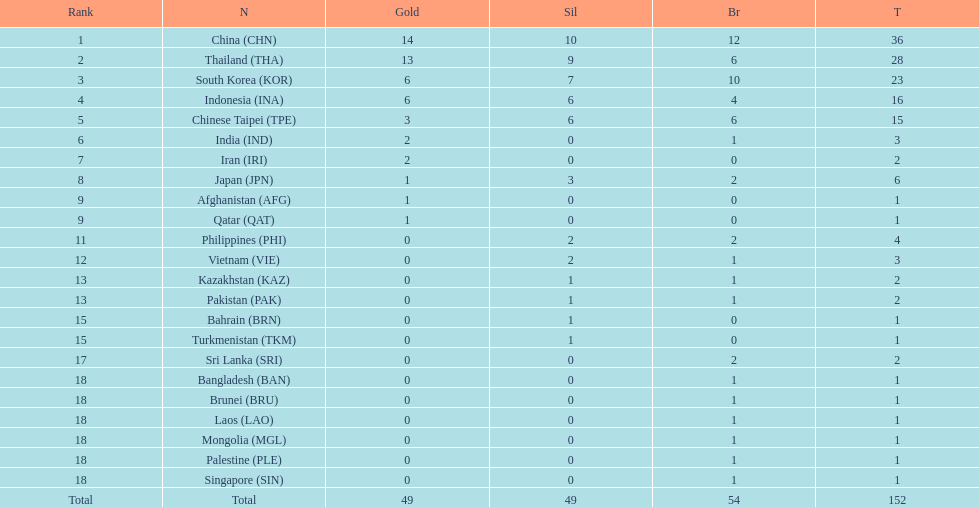What was the total of medals secured by indonesia (ina)? 16. Give me the full table as a dictionary. {'header': ['Rank', 'N', 'Gold', 'Sil', 'Br', 'T'], 'rows': [['1', 'China\xa0(CHN)', '14', '10', '12', '36'], ['2', 'Thailand\xa0(THA)', '13', '9', '6', '28'], ['3', 'South Korea\xa0(KOR)', '6', '7', '10', '23'], ['4', 'Indonesia\xa0(INA)', '6', '6', '4', '16'], ['5', 'Chinese Taipei\xa0(TPE)', '3', '6', '6', '15'], ['6', 'India\xa0(IND)', '2', '0', '1', '3'], ['7', 'Iran\xa0(IRI)', '2', '0', '0', '2'], ['8', 'Japan\xa0(JPN)', '1', '3', '2', '6'], ['9', 'Afghanistan\xa0(AFG)', '1', '0', '0', '1'], ['9', 'Qatar\xa0(QAT)', '1', '0', '0', '1'], ['11', 'Philippines\xa0(PHI)', '0', '2', '2', '4'], ['12', 'Vietnam\xa0(VIE)', '0', '2', '1', '3'], ['13', 'Kazakhstan\xa0(KAZ)', '0', '1', '1', '2'], ['13', 'Pakistan\xa0(PAK)', '0', '1', '1', '2'], ['15', 'Bahrain\xa0(BRN)', '0', '1', '0', '1'], ['15', 'Turkmenistan\xa0(TKM)', '0', '1', '0', '1'], ['17', 'Sri Lanka\xa0(SRI)', '0', '0', '2', '2'], ['18', 'Bangladesh\xa0(BAN)', '0', '0', '1', '1'], ['18', 'Brunei\xa0(BRU)', '0', '0', '1', '1'], ['18', 'Laos\xa0(LAO)', '0', '0', '1', '1'], ['18', 'Mongolia\xa0(MGL)', '0', '0', '1', '1'], ['18', 'Palestine\xa0(PLE)', '0', '0', '1', '1'], ['18', 'Singapore\xa0(SIN)', '0', '0', '1', '1'], ['Total', 'Total', '49', '49', '54', '152']]} 